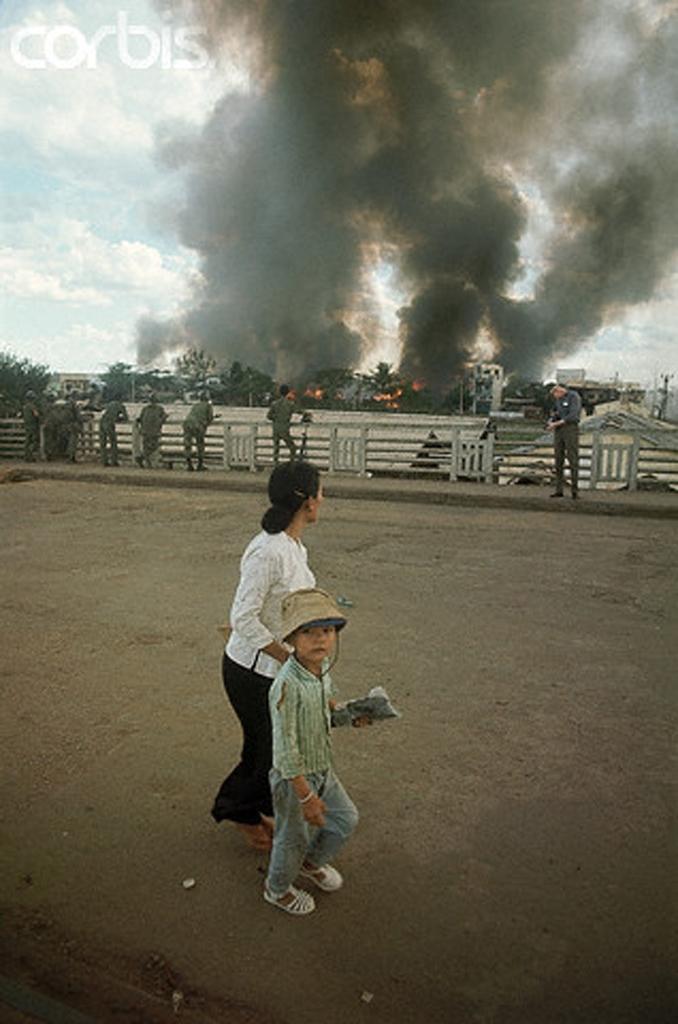In one or two sentences, can you explain what this image depicts? There is a woman and a child. Child is holding something and wearing a hat. In the back there are many people. Also there is railing, trees, smoke and fire. In the background there is sky. On the top left corner there is a watermark. 